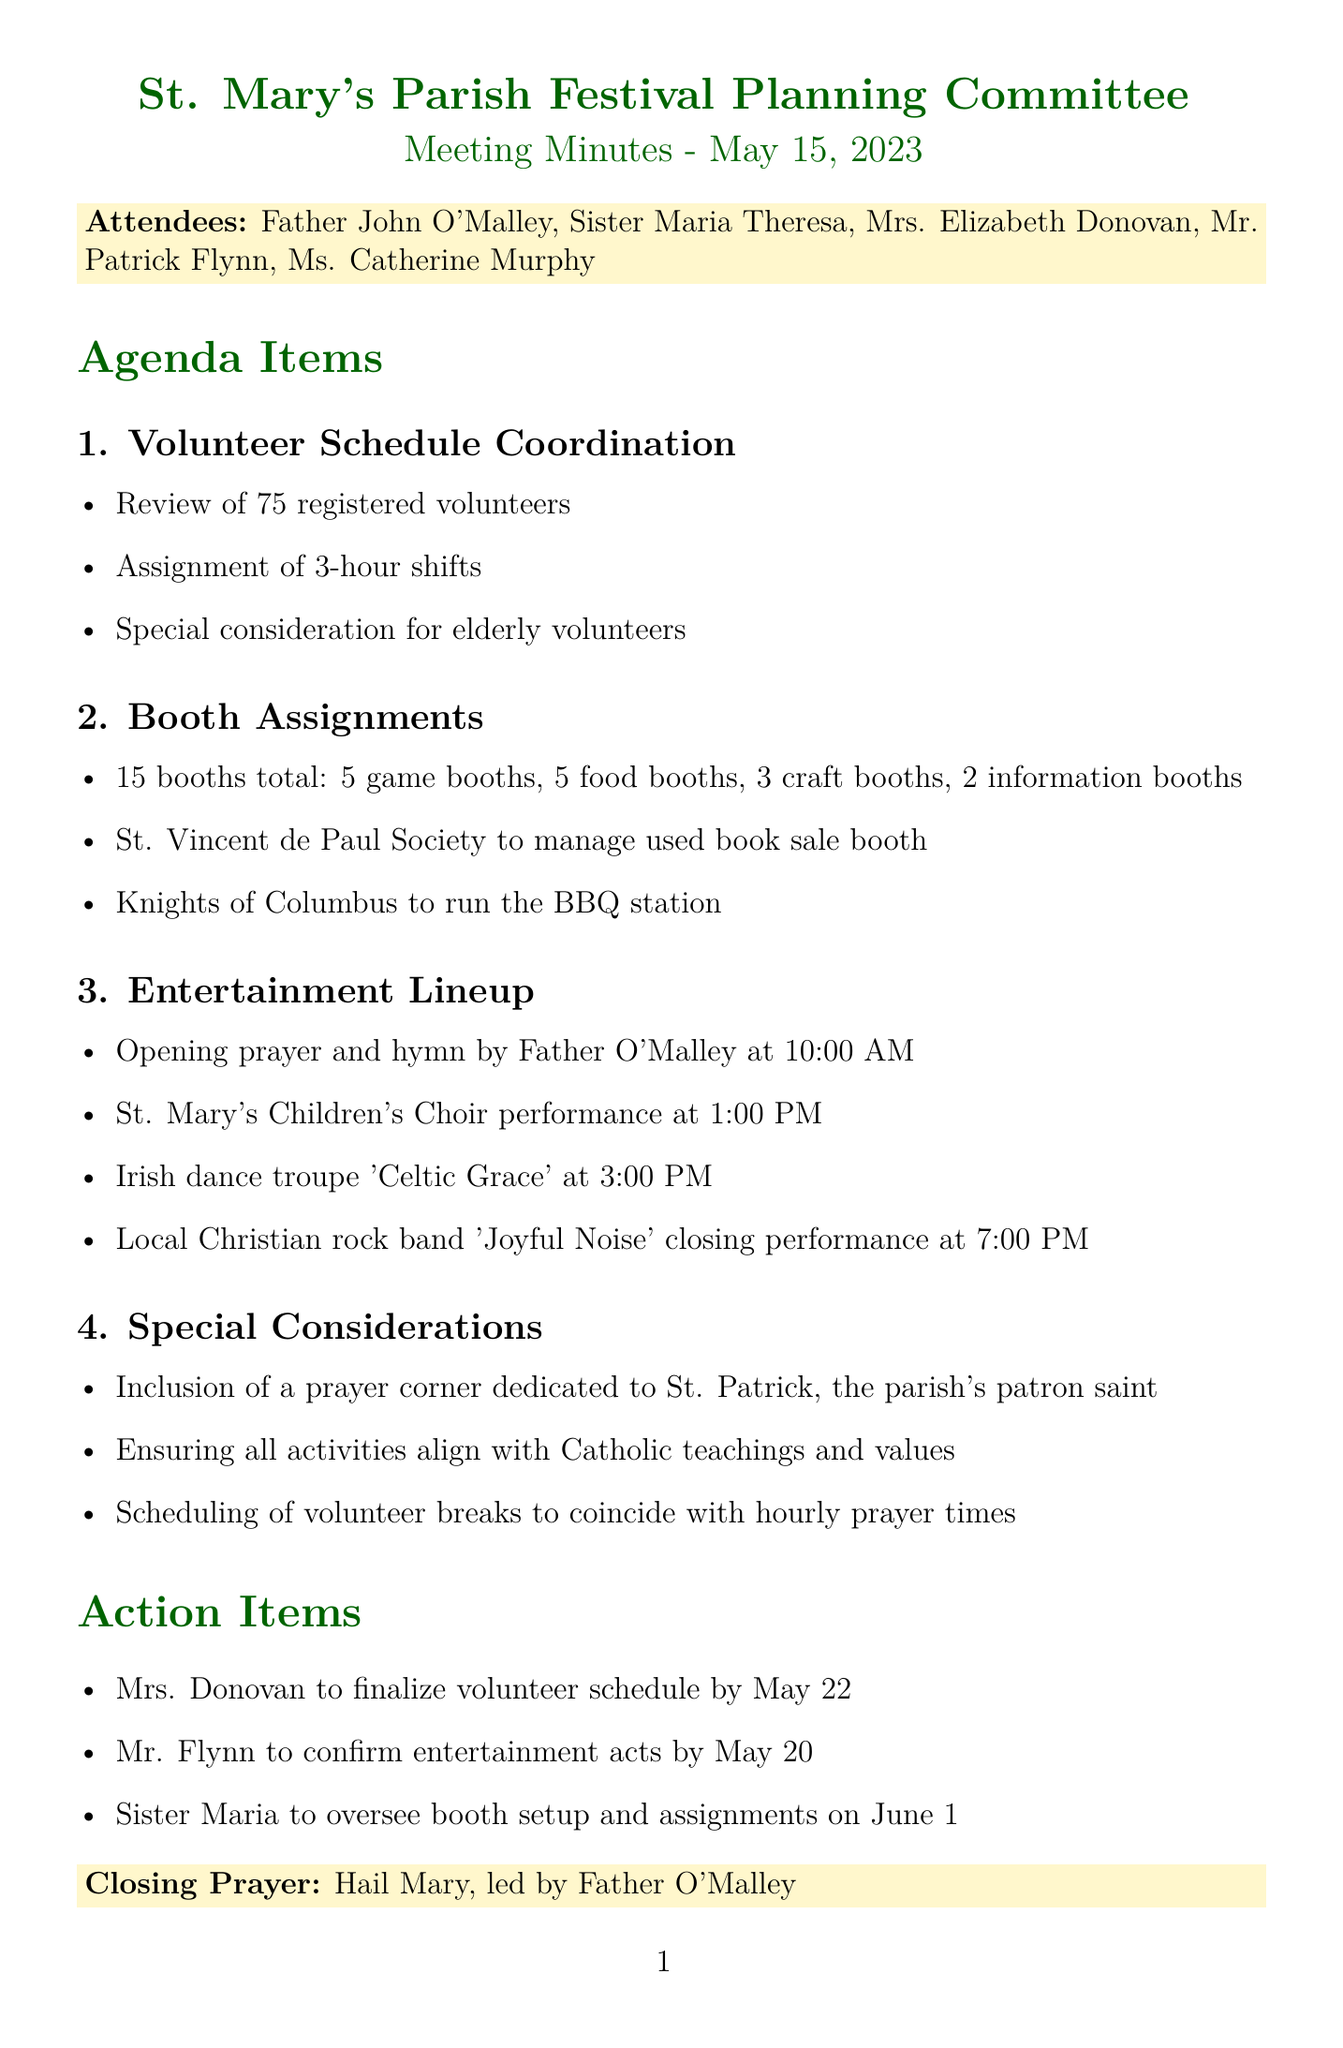What is the date of the meeting? The date of the meeting is mentioned in the document.
Answer: May 15, 2023 How many volunteers are registered for the festival? The number of registered volunteers is explicitly stated in the meeting minutes.
Answer: 75 registered volunteers What are the names of the booths? The document lists different types of booths to be assigned at the festival.
Answer: 5 game booths, 5 food booths, 3 craft booths, 2 information booths Who will manage the used book sale booth? The document specifies which organization will manage that booth.
Answer: St. Vincent de Paul Society What time is the closing performance by 'Joyful Noise'? The schedule details the time for the closing performance of the entertainment lineup.
Answer: 7:00 PM What special consideration is mentioned for elderly volunteers? The agenda item about volunteer schedule coordination includes a specific consideration.
Answer: Special consideration for elderly volunteers What is included in the special considerations section? The document outlines various special considerations related to the festival activities.
Answer: Inclusion of a prayer corner dedicated to St. Patrick Who is responsible for finalizing the volunteer schedule? The action items specify who is responsible for finalizing the volunteer schedule.
Answer: Mrs. Donovan What is the closing prayer mentioned in the document? The document concludes with a specific prayer led by Father O'Malley.
Answer: Hail Mary 